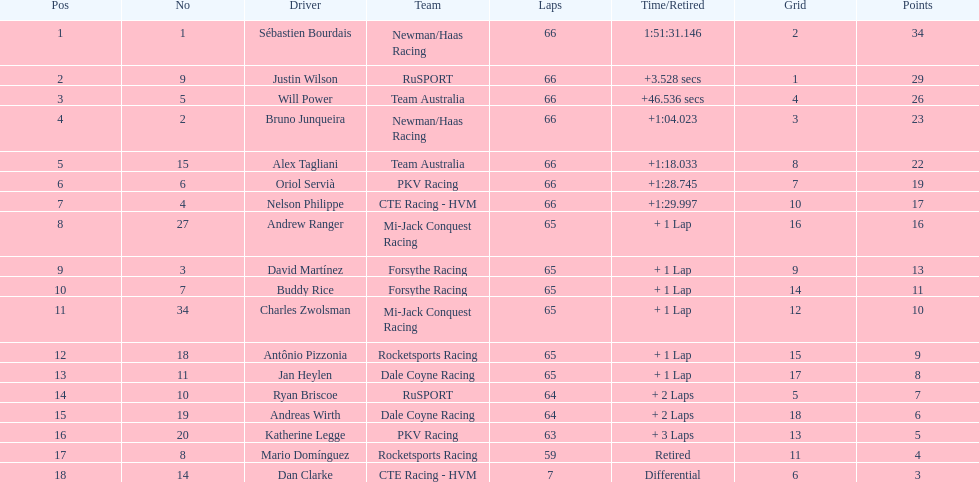How many drivers did not complete over 60 laps? 2. 